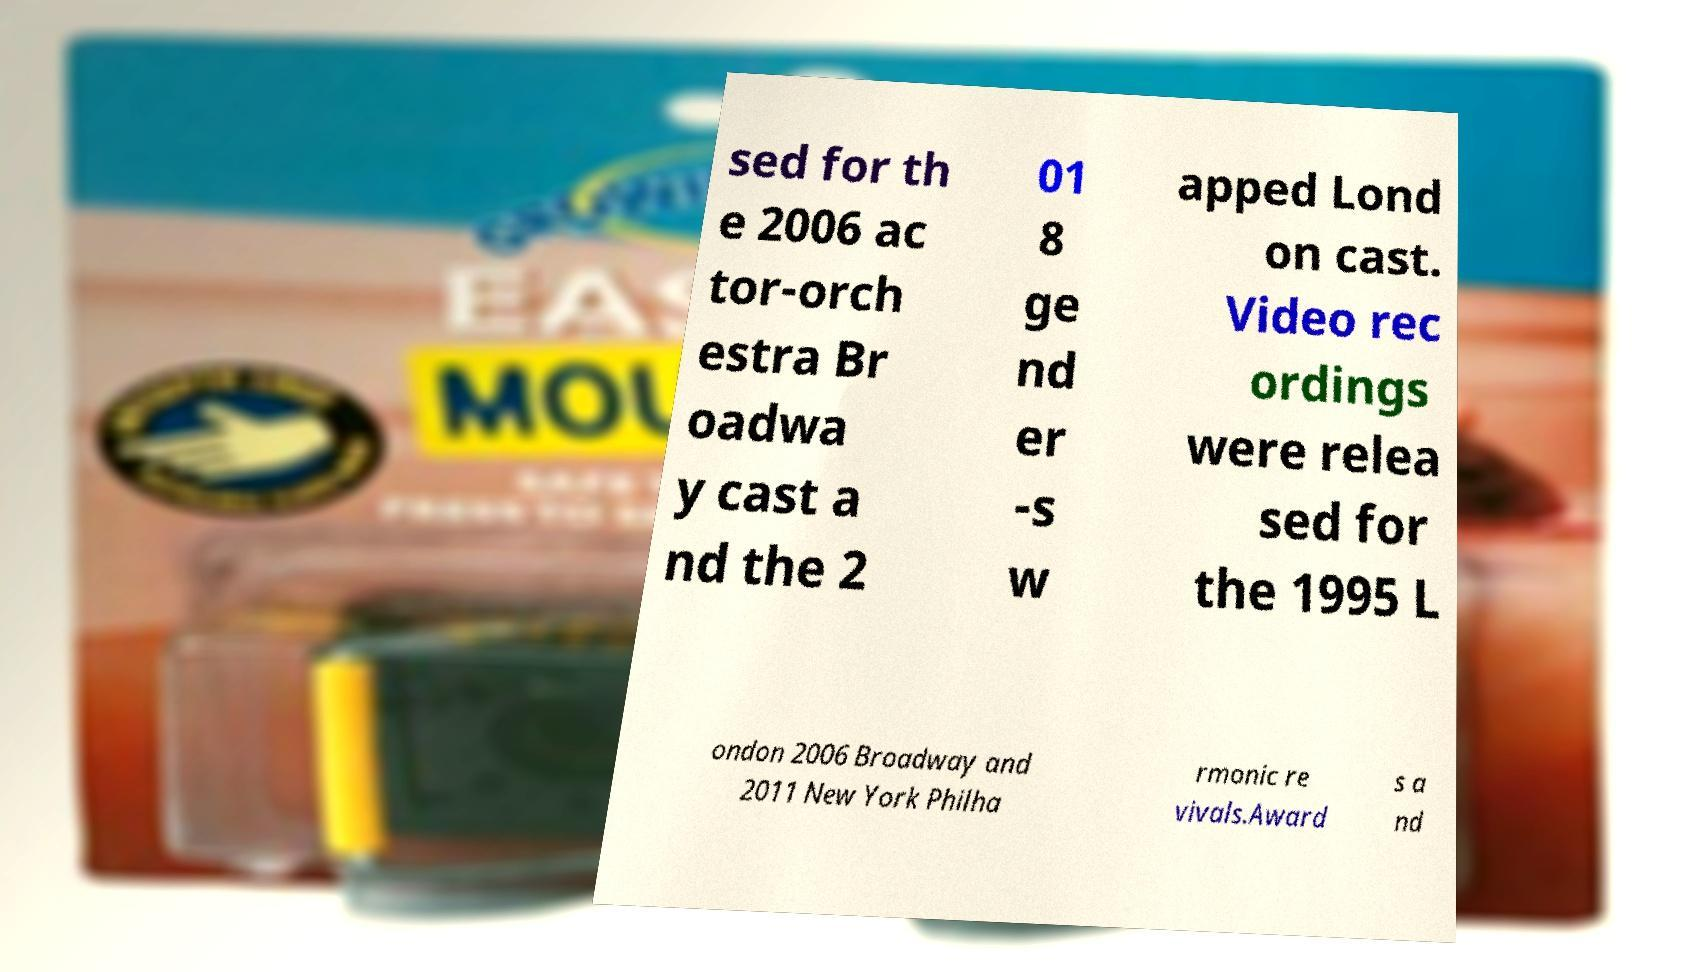I need the written content from this picture converted into text. Can you do that? sed for th e 2006 ac tor-orch estra Br oadwa y cast a nd the 2 01 8 ge nd er -s w apped Lond on cast. Video rec ordings were relea sed for the 1995 L ondon 2006 Broadway and 2011 New York Philha rmonic re vivals.Award s a nd 